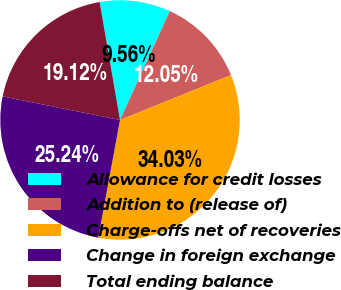<chart> <loc_0><loc_0><loc_500><loc_500><pie_chart><fcel>Allowance for credit losses<fcel>Addition to (release of)<fcel>Charge-offs net of recoveries<fcel>Change in foreign exchange<fcel>Total ending balance<nl><fcel>9.56%<fcel>12.05%<fcel>34.03%<fcel>25.24%<fcel>19.12%<nl></chart> 